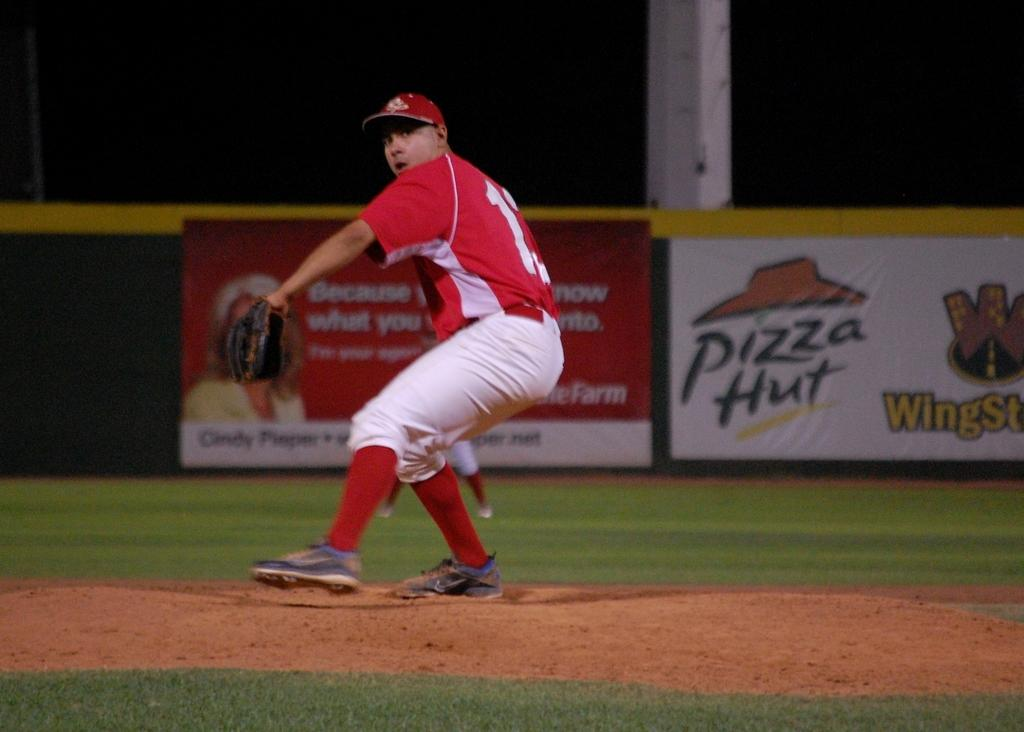Provide a one-sentence caption for the provided image. A pitcher throws while standing in front of a Pizza Hut ad. 